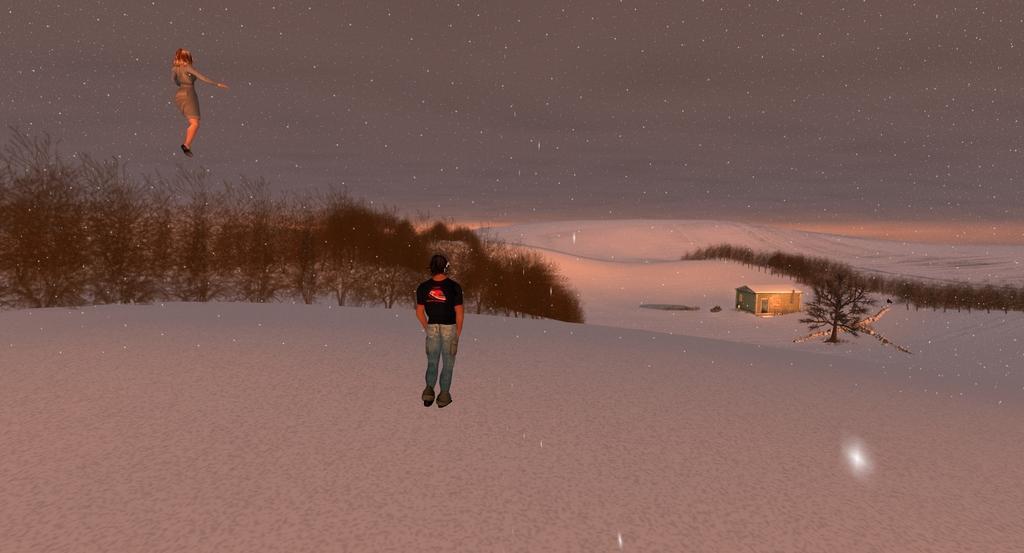In one or two sentences, can you explain what this image depicts? In this picture I can see the animated image. In the center there is a man who is standing on the ground. In the background I can see the mountain, trees, shed and snow. In the top left corner there is a woman who is standing in the air. At the top there is a sky. 